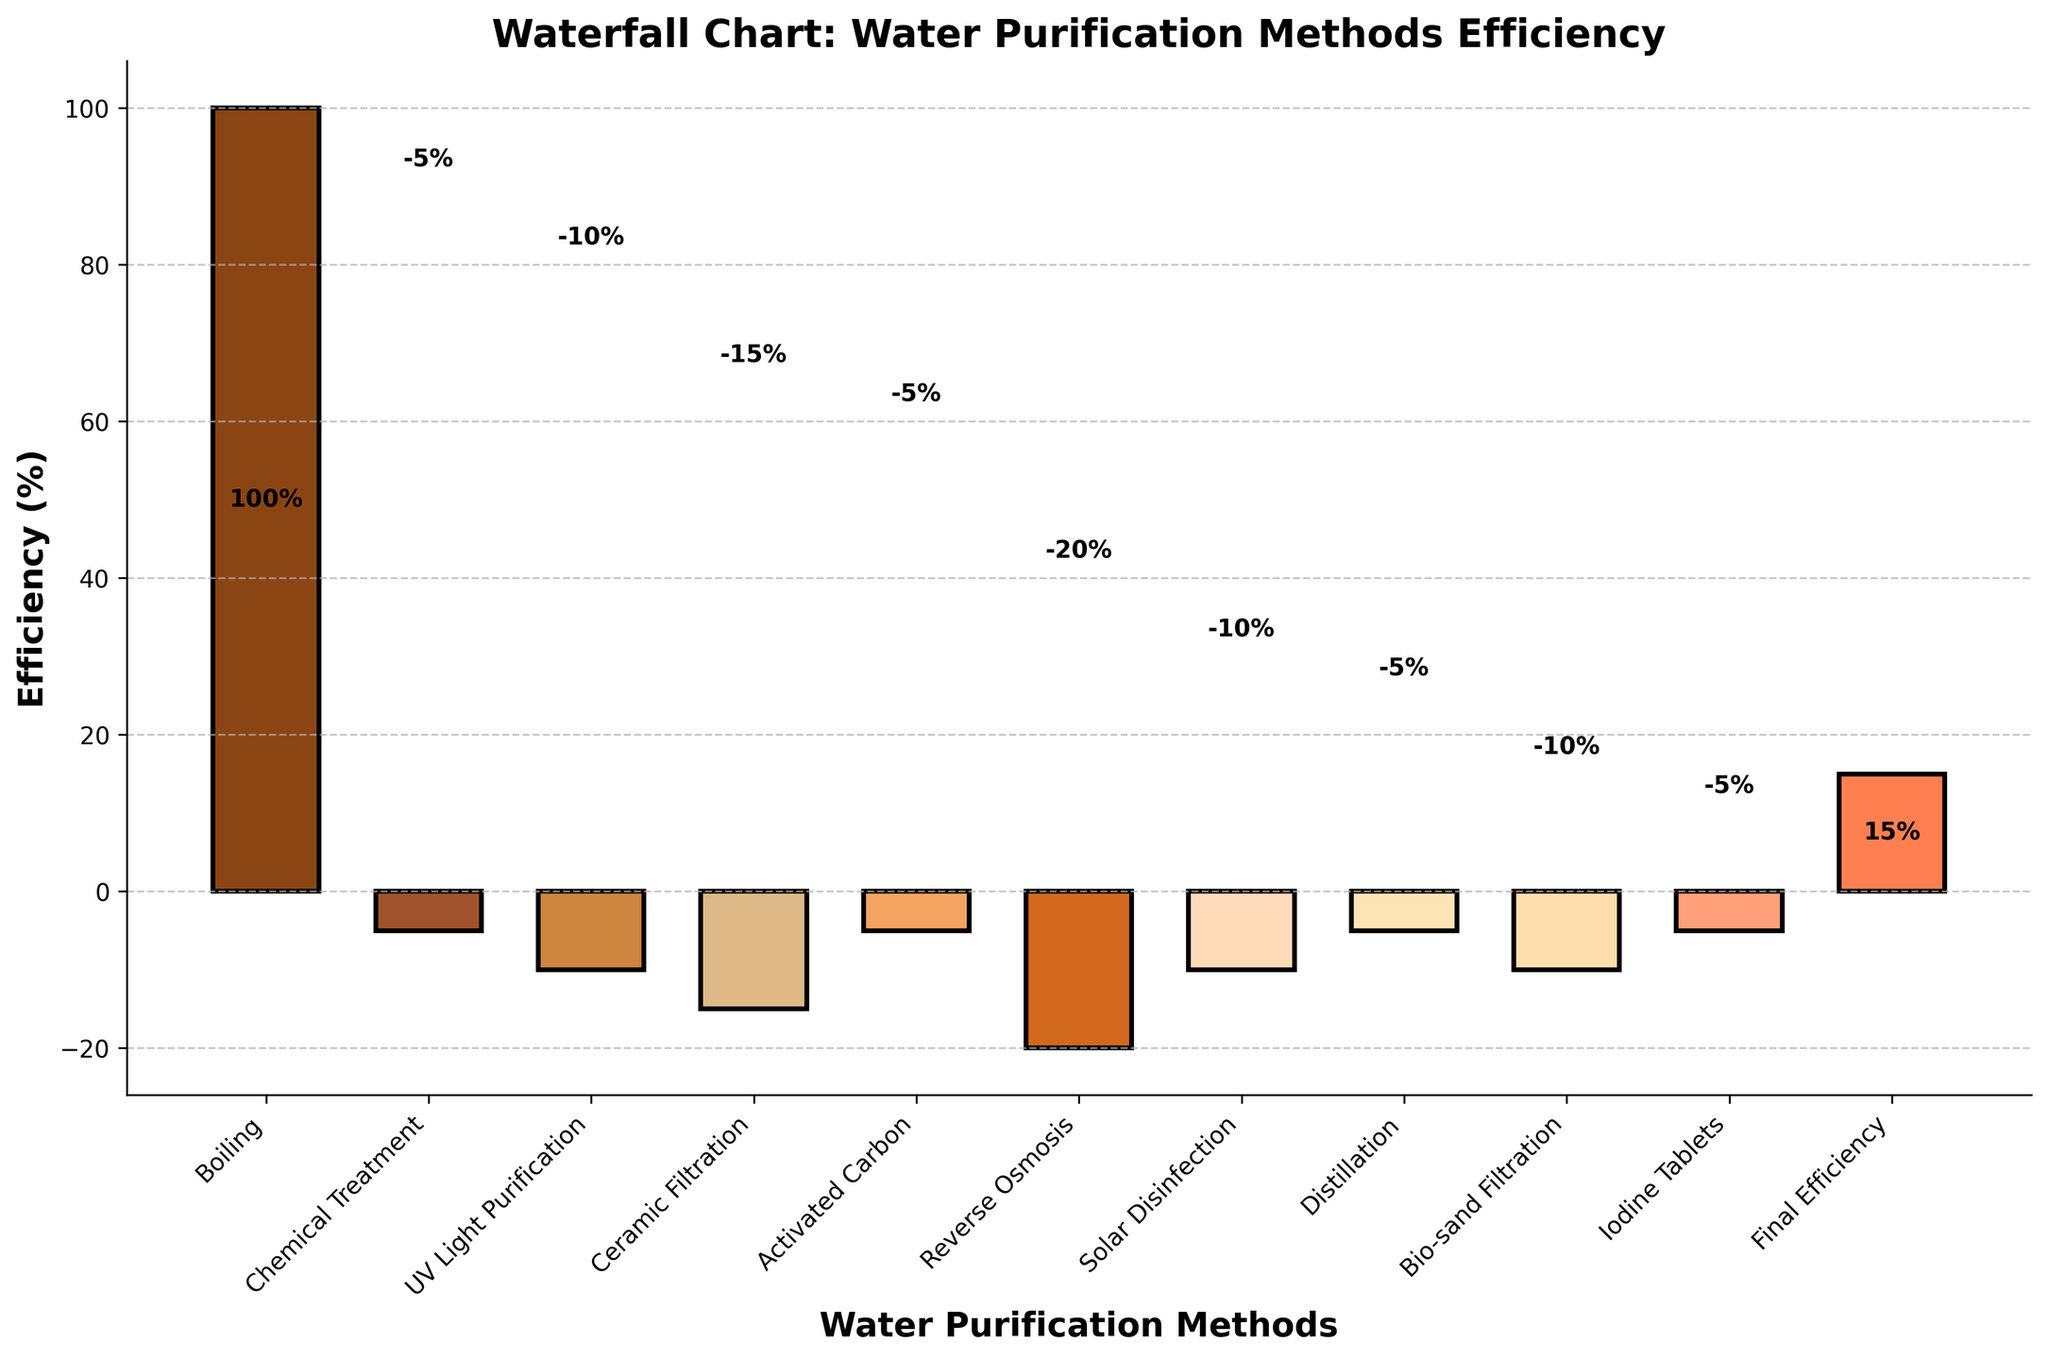What's the title of the figure? The title is typically displayed at the top of the figure. In this case, it reads 'Waterfall Chart: Water Purification Methods Efficiency'.
Answer: Waterfall Chart: Water Purification Methods Efficiency Which purification method has the highest initial efficiency? The initial efficiency can be seen on the first bar of the chart, labeled as 'Boiling', with an efficiency of 100%.
Answer: Boiling What is the final efficiency of water purification methods? The final efficiency is indicated at the last bar labeled 'Final Efficiency', showing an efficiency of 15%.
Answer: 15% How much efficiency is lost after chemical treatment? The change for chemical treatment is -5%, as indicated on the bar for 'Chemical Treatment'.
Answer: 5% Which method leads to the largest decrease in efficiency? By comparing the drop in efficiency for each method, 'Reverse Osmosis' has the highest drop of -20%.
Answer: Reverse Osmosis What is the cumulative efficiency loss after UV Light Purification? Starting from 100% (Boiling), the efficiency drops after chemical treatment by 5% (to 95%) and then by another 10% after UV Light Purification (to 85%).
Answer: 15% How does the efficiency of Ceramic Filtration compare to Solar Disinfection? The bar for 'Ceramic Filtration' reaches an efficiency of 70%, while 'Solar Disinfection' reaches an efficiency of 35%. Therefore, Ceramic Filtration has a higher efficiency by 35%.
Answer: Ceramic Filtration is 35% more efficient What is the overall efficiency loss between Boiling and Bio-sand Filtration? Boiling starts at 100%, and Bio-sand Filtration ends up at 20%. The overall efficiency loss is 100% - 20% = 80%.
Answer: 80% How much efficiency is retained after Activated Carbon treatment? After each method's drop, Activated Carbon shows a cumulative efficiency of 65%.
Answer: 65% Which method immediately follows Reverse Osmosis in terms of purification steps? The bar following 'Reverse Osmosis' is 'Solar Disinfection'.
Answer: Solar Disinfection 